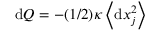<formula> <loc_0><loc_0><loc_500><loc_500>d Q = - ( 1 / 2 ) \kappa \left < d x _ { j } ^ { 2 } \right ></formula> 